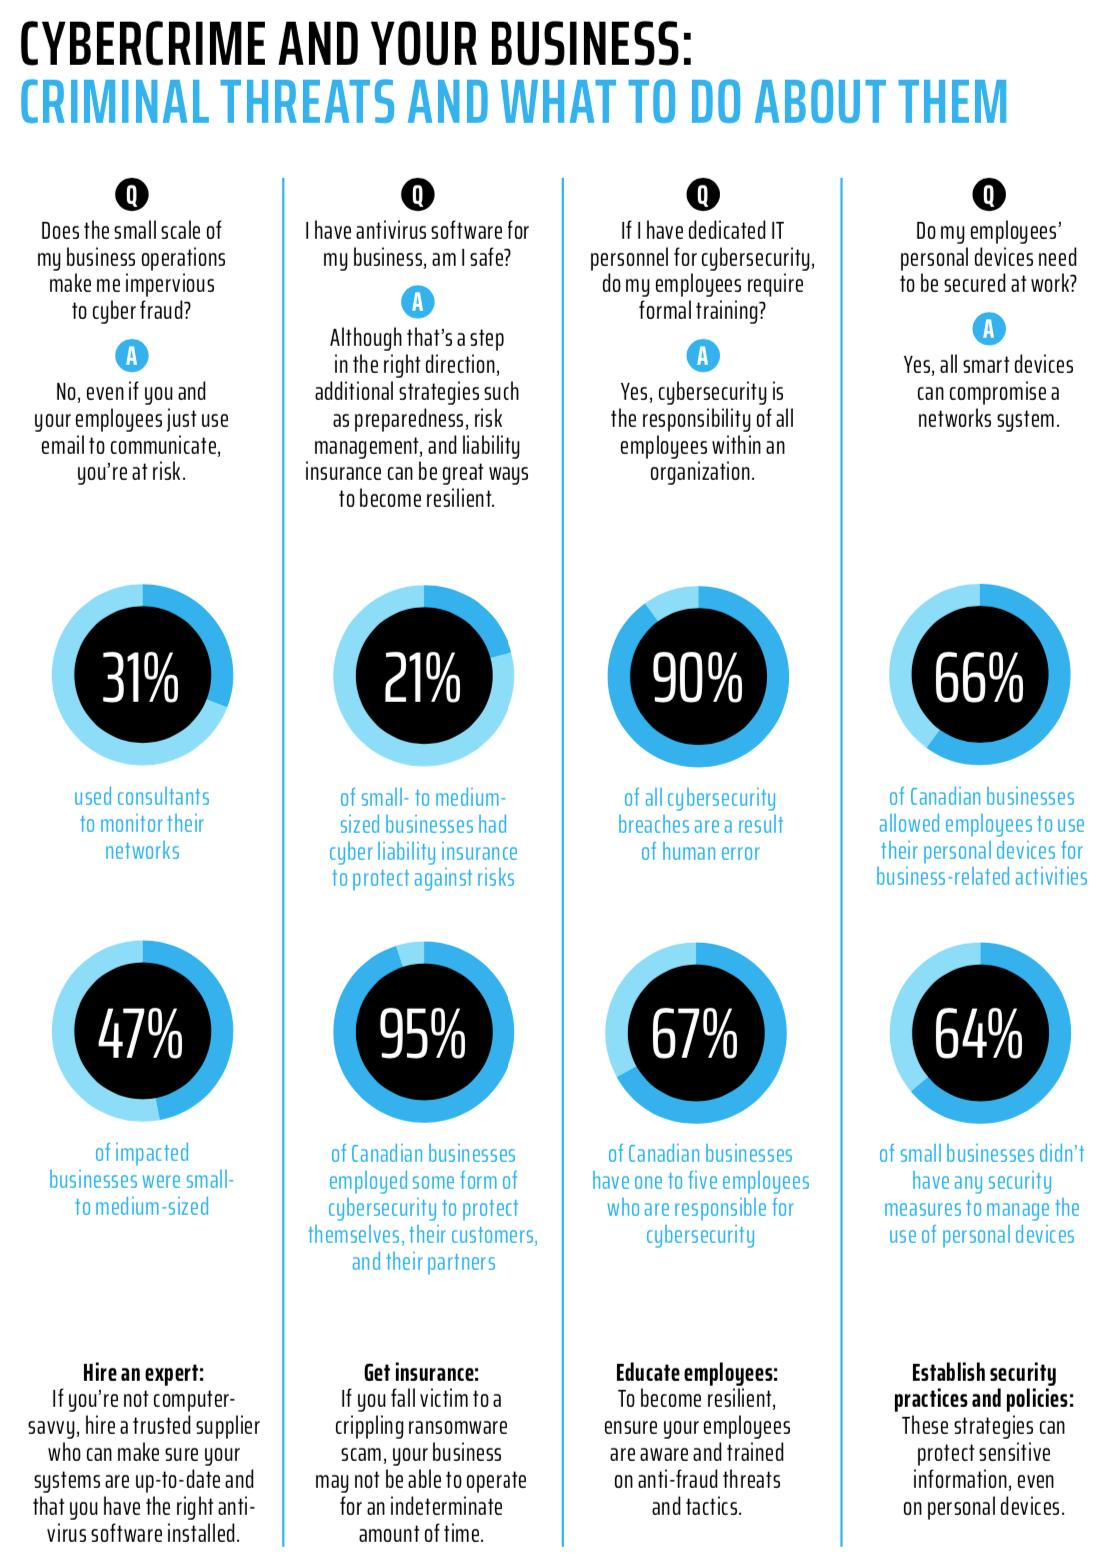Mention a couple of crucial points in this snapshot. Approximately 79% of businesses have insurance to prevent internet risks, according to a recent survey. The number of workers in a company responsible for internet security will range from one to five individuals. According to a study, a significant percentage of companies affected by internet security issues are not small-to-medium sized. It is estimated that approximately 5% of Canadian businesses have not deployed any internet security measures. Sixty-six percent of Canadian businesses have granted their employees permission to work with their own personal devices. 